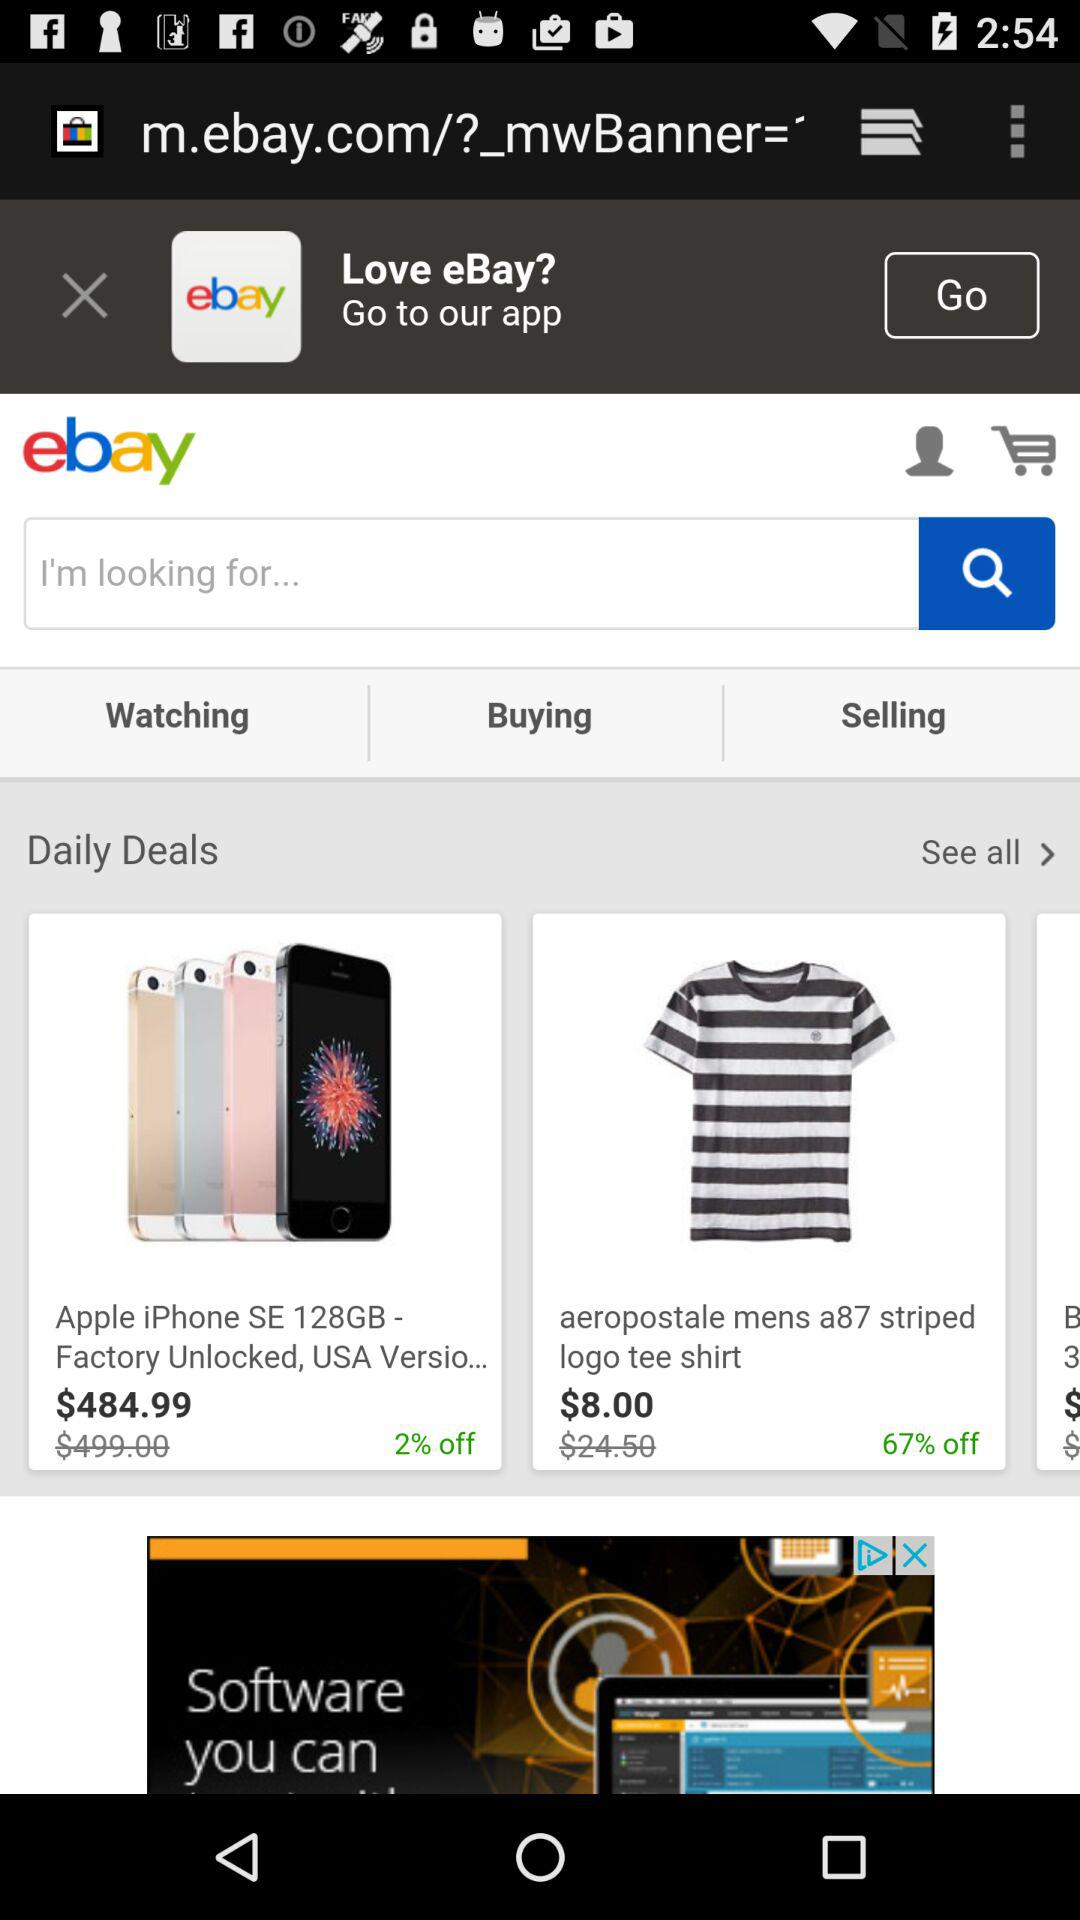What is the name of the application? The name of the application is "ebay". 